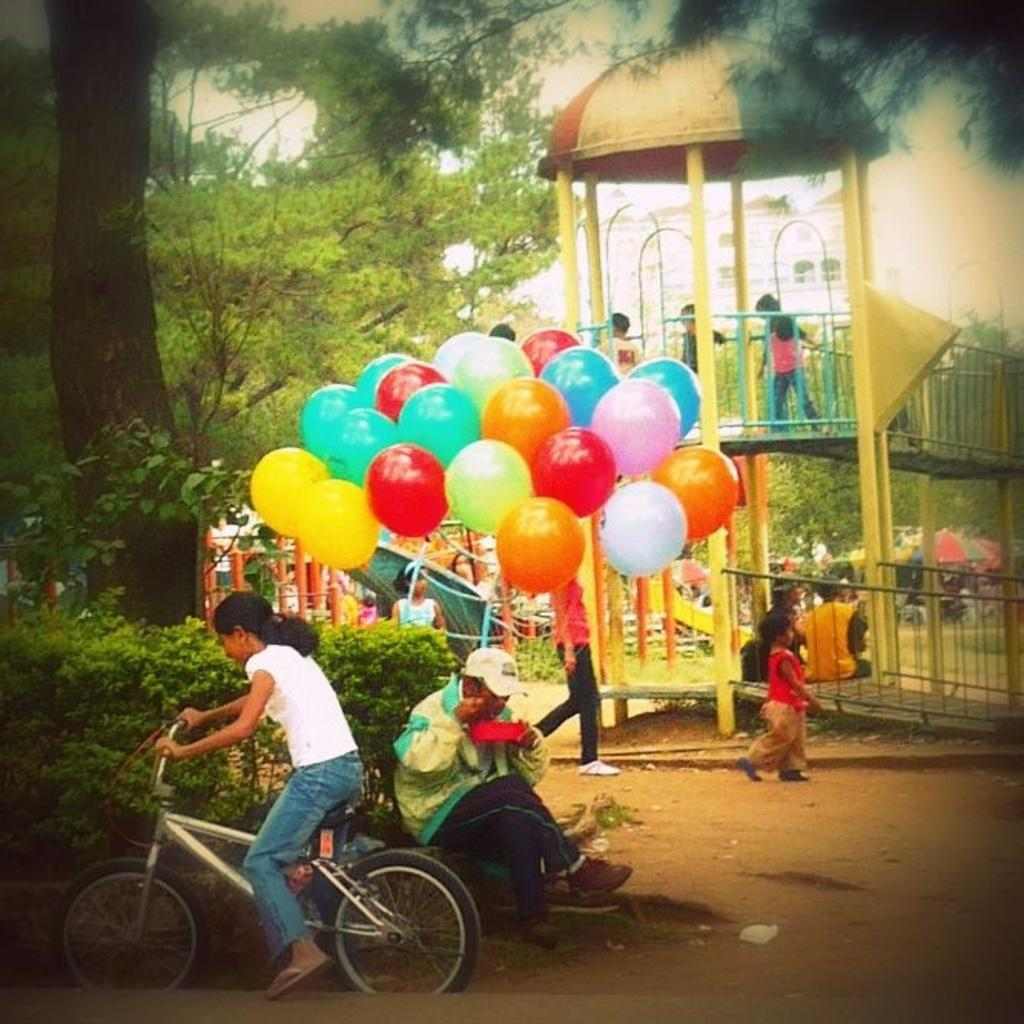What is the person in the image doing? There is a person sitting on a bicycle in the image. What can be seen in the background of the image? There are balloons, trees, and children in the background of the image. What type of kite is the person reading while smoking in the image? There is no kite, reading, or smoking present in the image. 